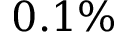Convert formula to latex. <formula><loc_0><loc_0><loc_500><loc_500>0 . 1 \%</formula> 